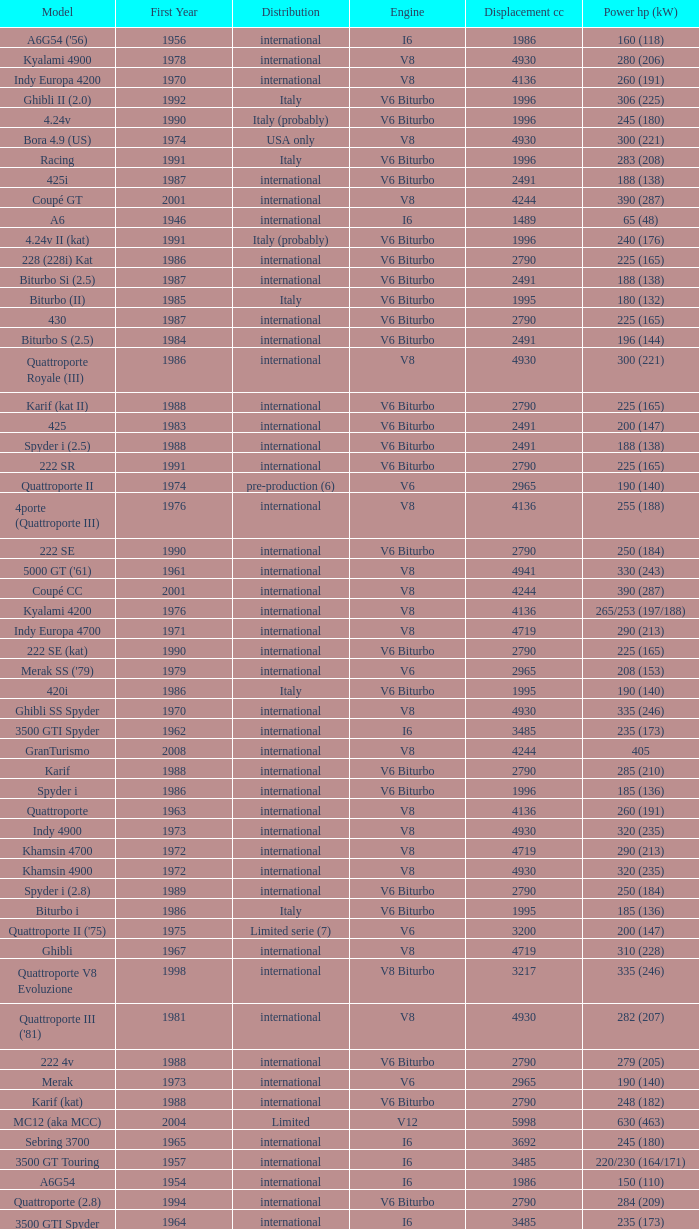What is the lowest First Year, when Model is "Quattroporte (2.8)"? 1994.0. 